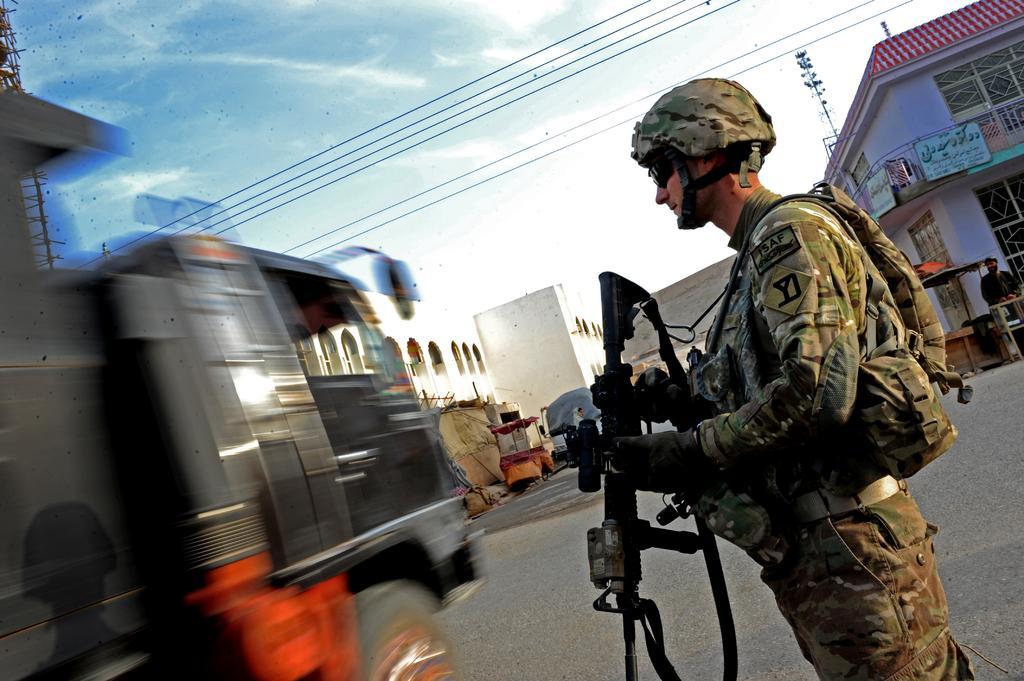Could you give a brief overview of what you see in this image? On the right side of this image there is a person wearing uniform, holding a gun in the hands and standing facing towards the left side. On the left side there is a vehicle on the road. In the background there are some buildings. On the right side there is a person standing in front of a table. In the background there are some other vehicles on the road. At the top of the image I can see the sky and also there are some wires. 